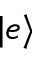<formula> <loc_0><loc_0><loc_500><loc_500>| e \rangle</formula> 